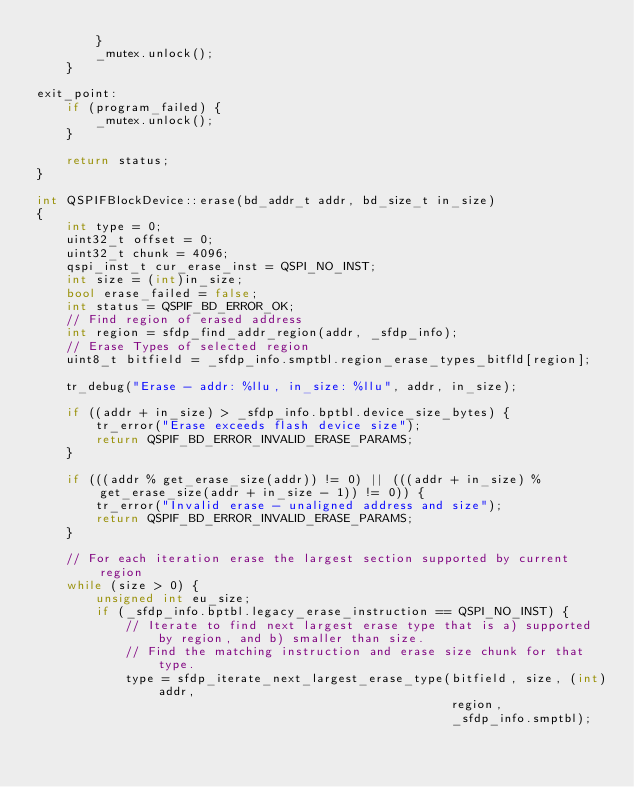Convert code to text. <code><loc_0><loc_0><loc_500><loc_500><_C++_>        }
        _mutex.unlock();
    }

exit_point:
    if (program_failed) {
        _mutex.unlock();
    }

    return status;
}

int QSPIFBlockDevice::erase(bd_addr_t addr, bd_size_t in_size)
{
    int type = 0;
    uint32_t offset = 0;
    uint32_t chunk = 4096;
    qspi_inst_t cur_erase_inst = QSPI_NO_INST;
    int size = (int)in_size;
    bool erase_failed = false;
    int status = QSPIF_BD_ERROR_OK;
    // Find region of erased address
    int region = sfdp_find_addr_region(addr, _sfdp_info);
    // Erase Types of selected region
    uint8_t bitfield = _sfdp_info.smptbl.region_erase_types_bitfld[region];

    tr_debug("Erase - addr: %llu, in_size: %llu", addr, in_size);

    if ((addr + in_size) > _sfdp_info.bptbl.device_size_bytes) {
        tr_error("Erase exceeds flash device size");
        return QSPIF_BD_ERROR_INVALID_ERASE_PARAMS;
    }

    if (((addr % get_erase_size(addr)) != 0) || (((addr + in_size) % get_erase_size(addr + in_size - 1)) != 0)) {
        tr_error("Invalid erase - unaligned address and size");
        return QSPIF_BD_ERROR_INVALID_ERASE_PARAMS;
    }

    // For each iteration erase the largest section supported by current region
    while (size > 0) {
        unsigned int eu_size;
        if (_sfdp_info.bptbl.legacy_erase_instruction == QSPI_NO_INST) {
            // Iterate to find next largest erase type that is a) supported by region, and b) smaller than size.
            // Find the matching instruction and erase size chunk for that type.
            type = sfdp_iterate_next_largest_erase_type(bitfield, size, (int)addr,
                                                        region,
                                                        _sfdp_info.smptbl);</code> 